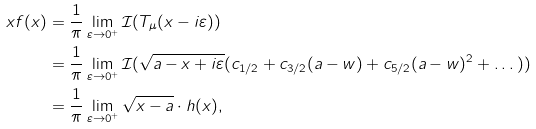<formula> <loc_0><loc_0><loc_500><loc_500>x f ( x ) & = \frac { 1 } { \pi } \lim _ { \varepsilon \to 0 ^ { + } } \mathcal { I } ( T _ { \mu } ( x - i \varepsilon ) ) \\ & = \frac { 1 } { \pi } \lim _ { \varepsilon \to 0 ^ { + } } \mathcal { I } ( \sqrt { a - x + i \varepsilon } ( c _ { 1 / 2 } + c _ { 3 / 2 } ( a - w ) + c _ { 5 / 2 } ( a - w ) ^ { 2 } + \dots ) ) \\ & = \frac { 1 } { \pi } \lim _ { \varepsilon \to 0 ^ { + } } \sqrt { x - a } \cdot h ( x ) ,</formula> 